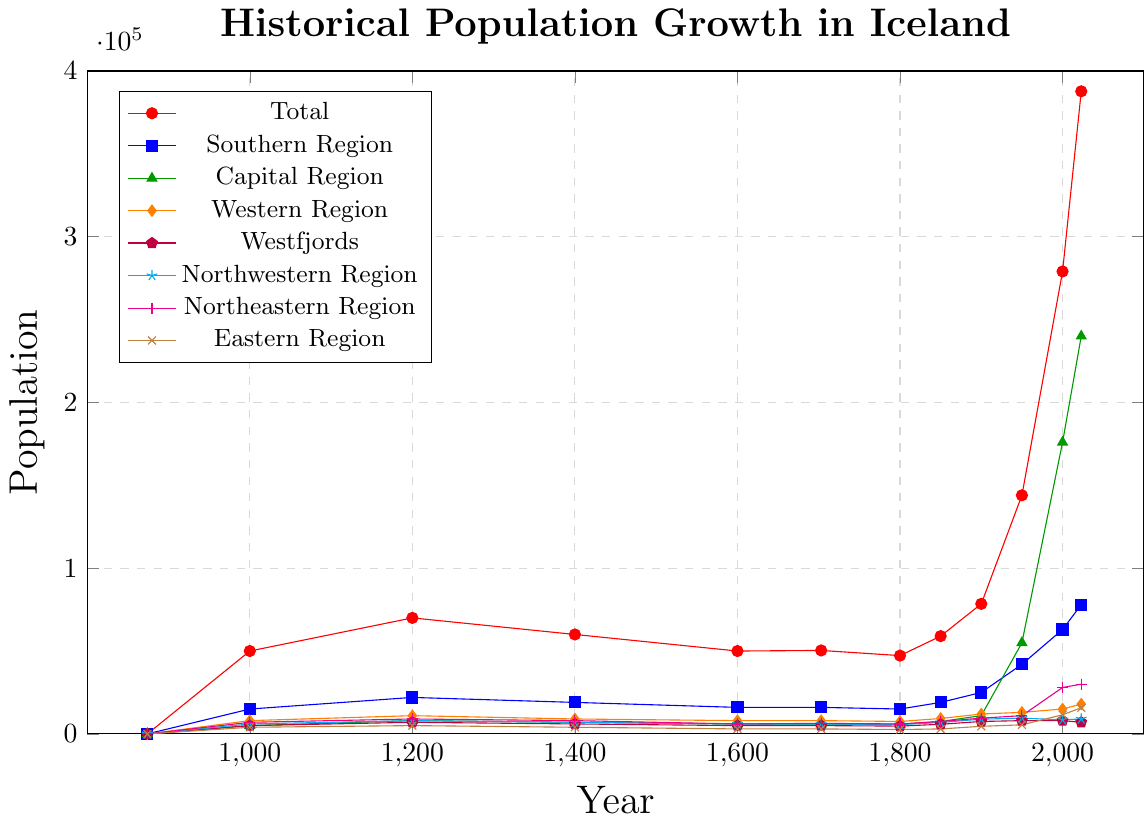What year did Iceland's total population first exceed 100,000? By looking at the 'Total' line (red), find the year where the population first crosses 100,000. This occurs between the points for 1900 and 1950, so examining the datapoints, it first surpasses 100,000 in 1950.
Answer: 1950 How much did the population of the Capital Region increase between 1950 and 2000? Find the population values of the Capital Region (blue) in 1950 and 2000. In 1950, it is 55,000 and in 2000, it is 176,000. The increase is 176,000 - 55,000 = 121,000.
Answer: 121,000 Which region had the smallest population in 2023? By comparing the population values for each region in 2023, find the smallest one. The smallest value is for the Westfjords (orange), which is 7,000.
Answer: Westfjords Between 1400 and 1600, which region's population declined the most? Compare population values for 1400 and 1600 for each region and find the difference. The region with the largest negative difference is the Southern Region (red) with a decline from 19,000 to 16,000, a drop of 3,000.
Answer: Southern Region How many years did it take for the total population to double from 1900 to 1950? The total population in 1900 is 78,470 and in 1950 is 143,973. Doubling 78,470 gives roughly 156,940, which occurs around the 1950 mark. Subtract the years 1950 and 1900 to find the difference, 1950 - 1900 = 50.
Answer: 50 In which year did the Eastern Region's population first exceed 10,000? Observe the Eastern Region line (brown) to find the year where it first crosses 10,000. This happens between 1950 and 2000, so examining the datapoints, it first surpasses 10,000 in 2000.
Answer: 2000 Which regions had an increase in population between 1400 and 1600? Calculate the population differences for each region between 1400 and 1600. The regions with increasing populations are the only ones with a positive difference. There are none as all regions depict a decline during this period.
Answer: None What is the combined population of the Northwestern and Northeastern Regions in 2023? Find the 2023 population values for Northwestern (cyan) and Northeastern Regions (magenta), which are 9,000 and 30,000, respectively. Summing these gives 9,000 + 30,000 = 39,000.
Answer: 39,000 By how much did the total population change from 1703 to 2023? Subtract the total population of 1703 from that of 2023. In 1703, the population was 50,358 and in 2023, it is 387,758. The change is 387,758 - 50,358 = 337,400.
Answer: 337,400 